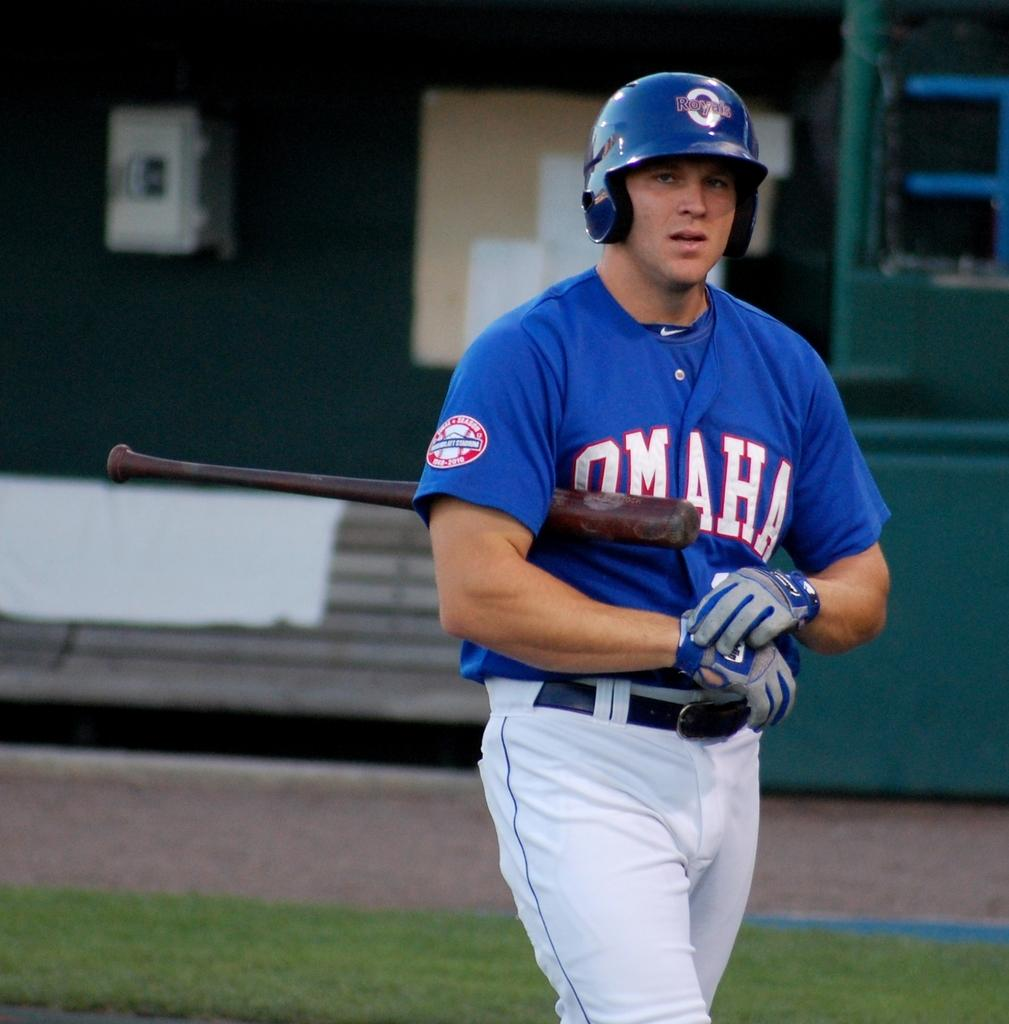<image>
Present a compact description of the photo's key features. A player wearing a blue jersey for Omaha stands on the field 